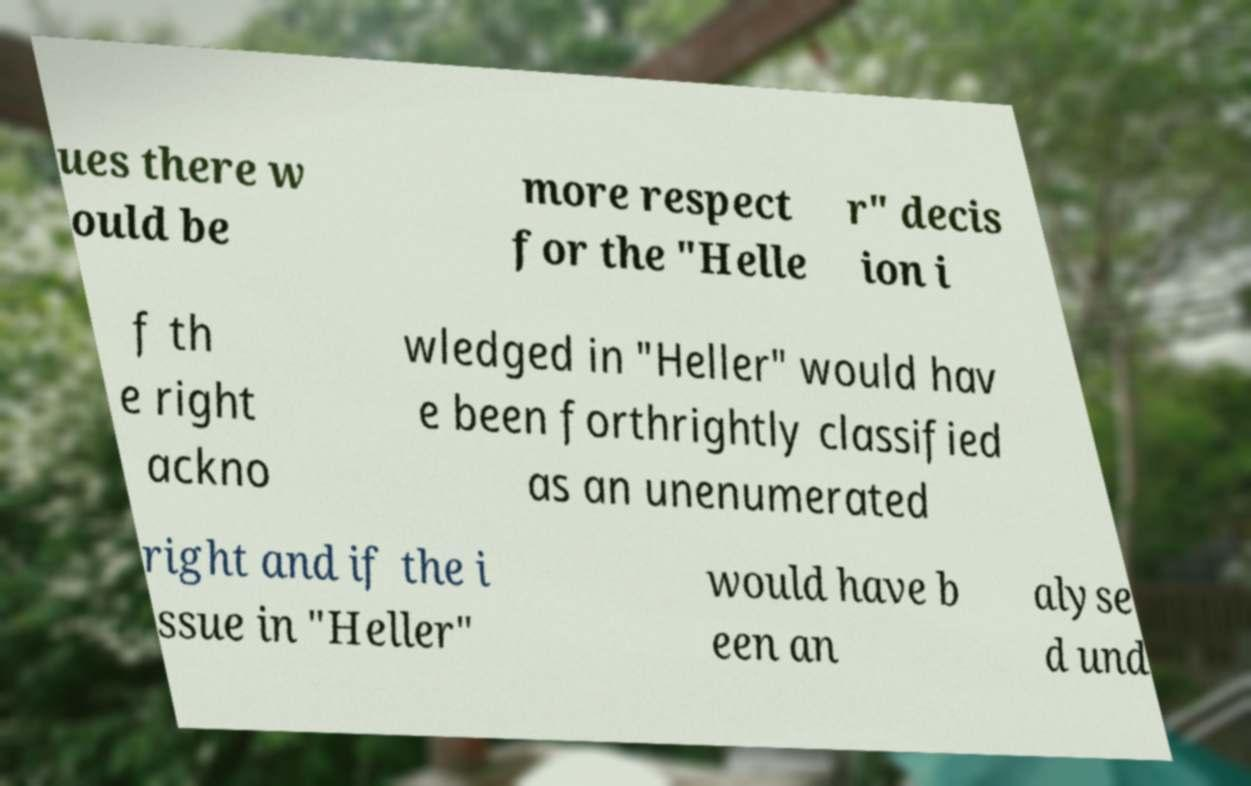There's text embedded in this image that I need extracted. Can you transcribe it verbatim? ues there w ould be more respect for the "Helle r" decis ion i f th e right ackno wledged in "Heller" would hav e been forthrightly classified as an unenumerated right and if the i ssue in "Heller" would have b een an alyse d und 